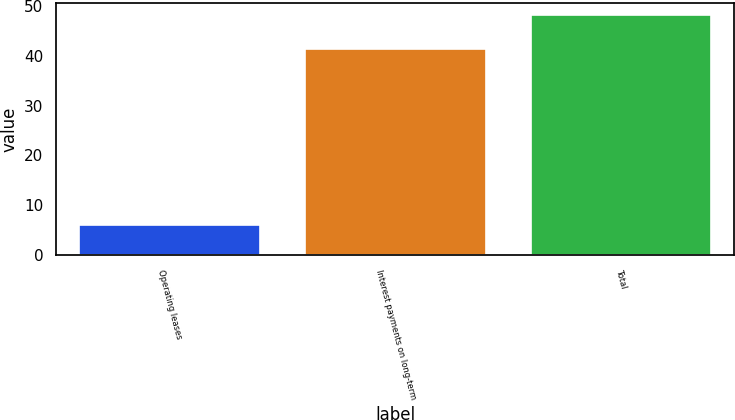<chart> <loc_0><loc_0><loc_500><loc_500><bar_chart><fcel>Operating leases<fcel>Interest payments on long-term<fcel>Total<nl><fcel>6.1<fcel>41.3<fcel>48.1<nl></chart> 